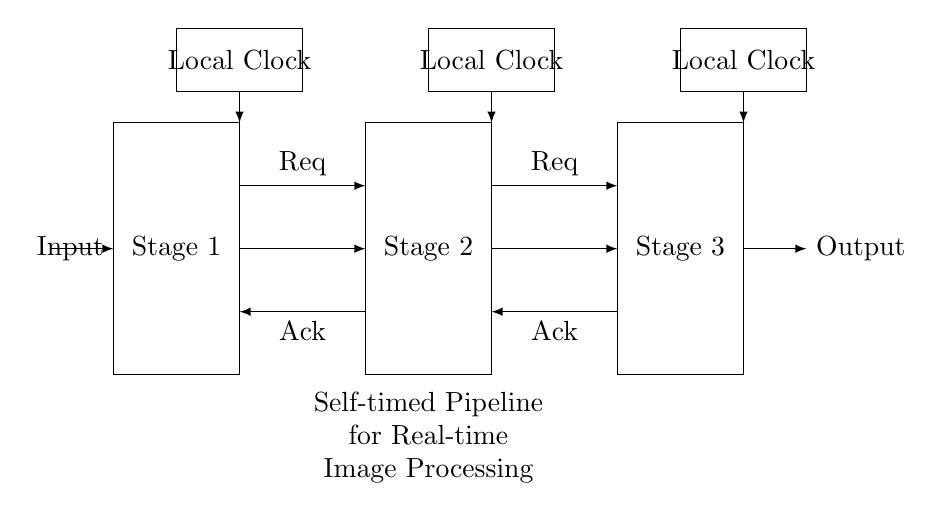What are the names of the pipeline stages? The diagram indicates three stages, labeled as Stage 1, Stage 2, and Stage 3. I can determine this by looking at the rectangles in the circuit, where each rectangle has a label in the center.
Answer: Stage 1, Stage 2, Stage 3 How many local clocks are present in the circuit? There are three local clocks shown in the circuit diagram, each represented by rectangles labeled “Local Clock.” They are located above each stage.
Answer: 3 What do the arrows between the stages represent? The arrows connecting the stages indicate data flow from one stage to the next. Each arrow points from the output of one stage to the input of the next, showing a sequential process.
Answer: Data flow What are the names of the handshake signals? The handshake signals are labeled “Req” for request and “Ack” for acknowledgment, which are indicated by the arrows connecting the stages at the appropriate locations.
Answer: Req, Ack What is the purpose of the self-timed pipeline in image processing? A self-timed pipeline optimizes data handling in real-time image processing by allowing each stage to operate independently, enabling efficient processing without waiting for a global clock signal.
Answer: Optimization What does the circuit signify by using local clocks? The use of local clocks indicates that each stage can conduct operations at its own pace, enhancing efficiency and flexibility in processing data while reducing synchronization overhead between stages.
Answer: Efficiency How is data output represented in the circuit? The data output is represented by the rightmost arrow labeled “Output” which shows the final result is produced after passing through all stages of the pipeline.
Answer: Output 